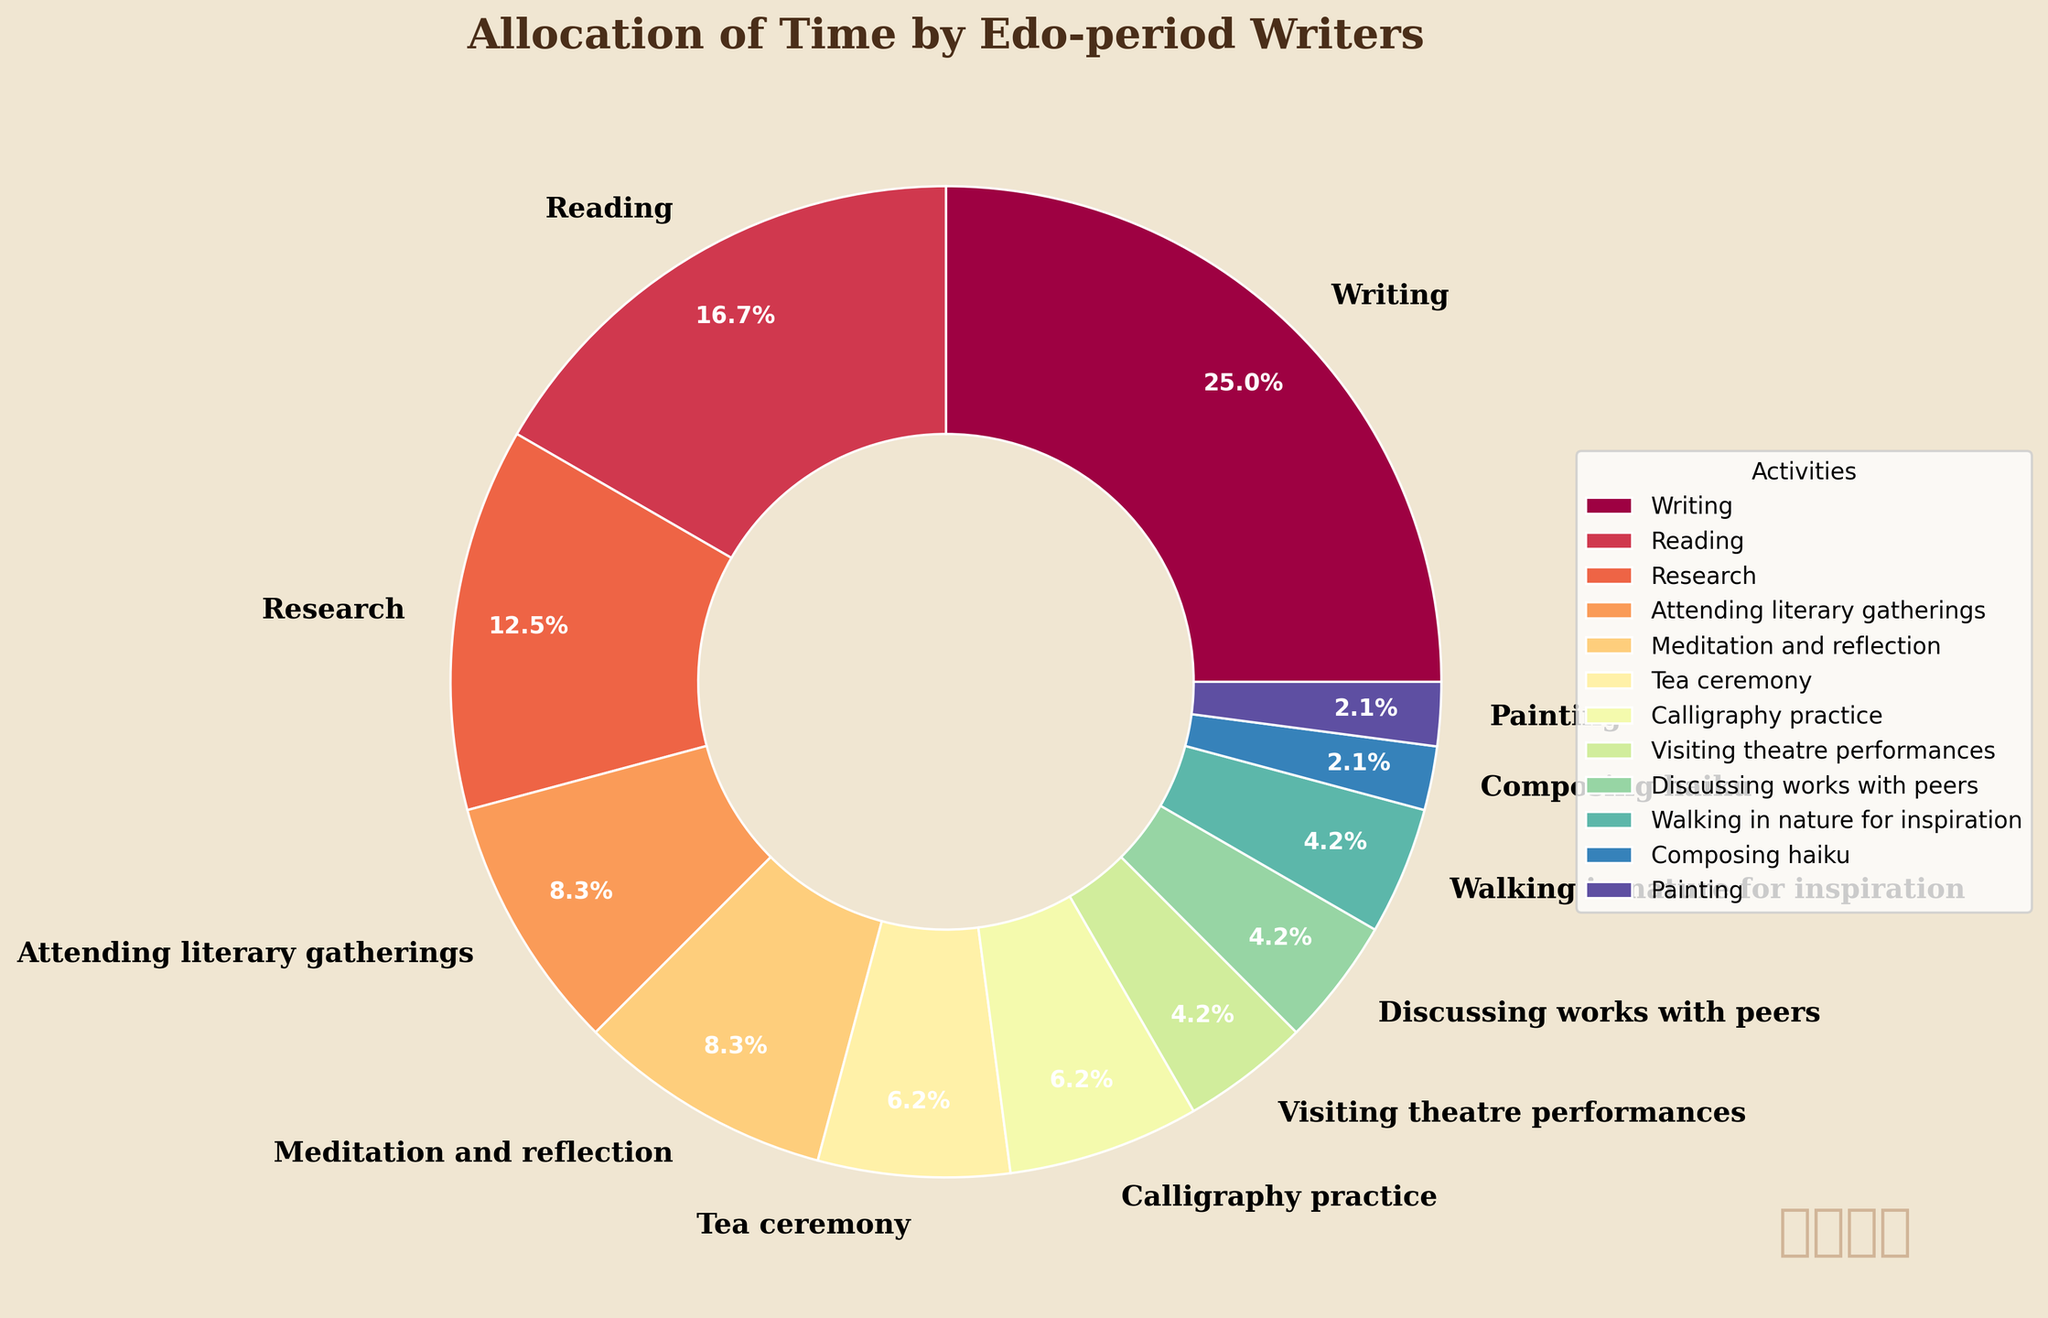How many hours in total were spent on activities other than writing and reading? First, we sum the hours spent on writing and reading: 6 (writing) + 4 (reading) = 10 hours. Then, we subtract this from the total hours spent on all activities, which is the sum of all provided hours: 6 + 4 + 3 + 2 + 2 + 1.5 + 1.5 + 1 + 1 + 1 + 0.5 + 0.5 = 24 hours. Thus, 24 - 10 = 14 hours.
Answer: 14 hours Which activity took up the most time, and how many hours were spent on it? The activity that took the most time is writing with 6 hours.
Answer: Writing, 6 hours Between calligraphy practice and tea ceremony, which activity took up more time? Calligraphy practice and tea ceremony each took 1.5 hours. Since both activities have the same number of hours, neither took up more time than the other.
Answer: Both are equal What is the percentage of time spent on composing haiku relative to the total hours? First, find the total hours, which is 24. Next, calculate the percentage: (0.5 / 24) * 100 = 2.08%.
Answer: 2.08% How much more time was spent on meditation and reflection compared to painting? Meditation and reflection took 2 hours, while painting took 0.5 hours. The difference is 2 - 0.5 = 1.5 hours.
Answer: 1.5 hours What is the average time spent on research and attending literary gatherings? The time spent on research is 3 hours, and on attending literary gatherings is 2 hours. The average is (3 + 2) / 2 = 2.5 hours.
Answer: 2.5 hours Which activities took the least amount of time and how much time was spent on them? Composing haiku and painting each took the least amount of time, with 0.5 hours each.
Answer: Composing haiku and painting, 0.5 hours each What is the combined percentage of time spent on attending literary gatherings and discussing works with peers? First, find the total hours, which is 24. Next, find the sum of hours for these activities: 2 (attending literary gatherings) + 1 (discussing works with peers) = 3 hours. Finally, calculate the percentage: (3 / 24) * 100 = 12.5%.
Answer: 12.5% How does the time spent walking in nature for inspiration compare to the time spent visiting theatre performances? Both activities took 1 hour each, so they are equal in time spent.
Answer: Equal What activities took exactly 1 hour each? Walking in nature for inspiration and visiting theatre performances each took exactly 1 hour.
Answer: Walking in nature for inspiration, visiting theatre performances 